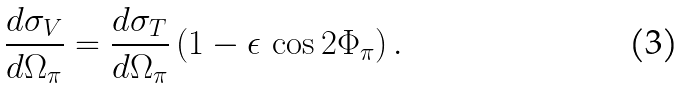Convert formula to latex. <formula><loc_0><loc_0><loc_500><loc_500>\frac { d \sigma _ { V } } { d \Omega _ { \pi } } = \frac { d \sigma _ { T } } { d \Omega _ { \pi } } \, ( 1 - \epsilon \, \cos { 2 \Phi _ { \pi } } ) \, .</formula> 